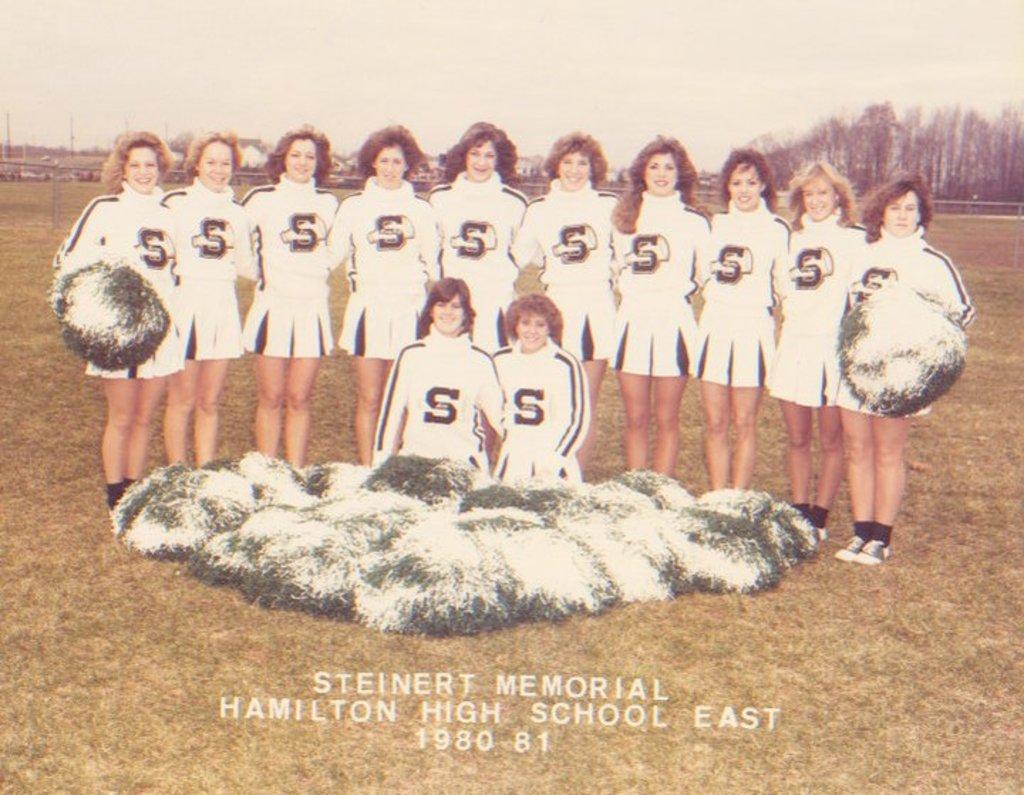What high school do they cheer for?
Offer a terse response. Steinert memorial hamilton high school east. 